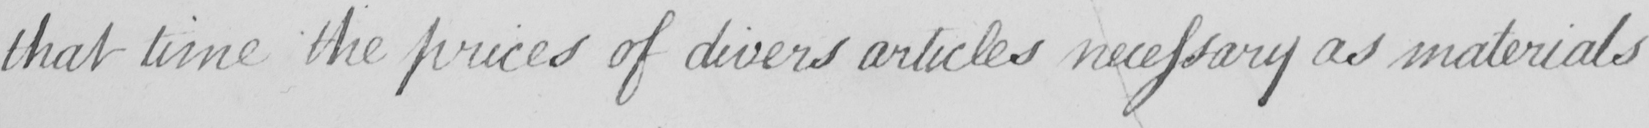What text is written in this handwritten line? that time the prices of divers articles necessary as materials 